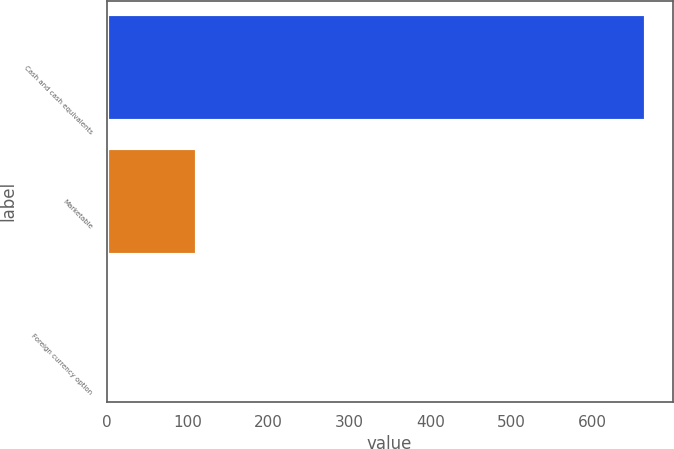Convert chart. <chart><loc_0><loc_0><loc_500><loc_500><bar_chart><fcel>Cash and cash equivalents<fcel>Marketable<fcel>Foreign currency option<nl><fcel>665.9<fcel>112<fcel>0.1<nl></chart> 